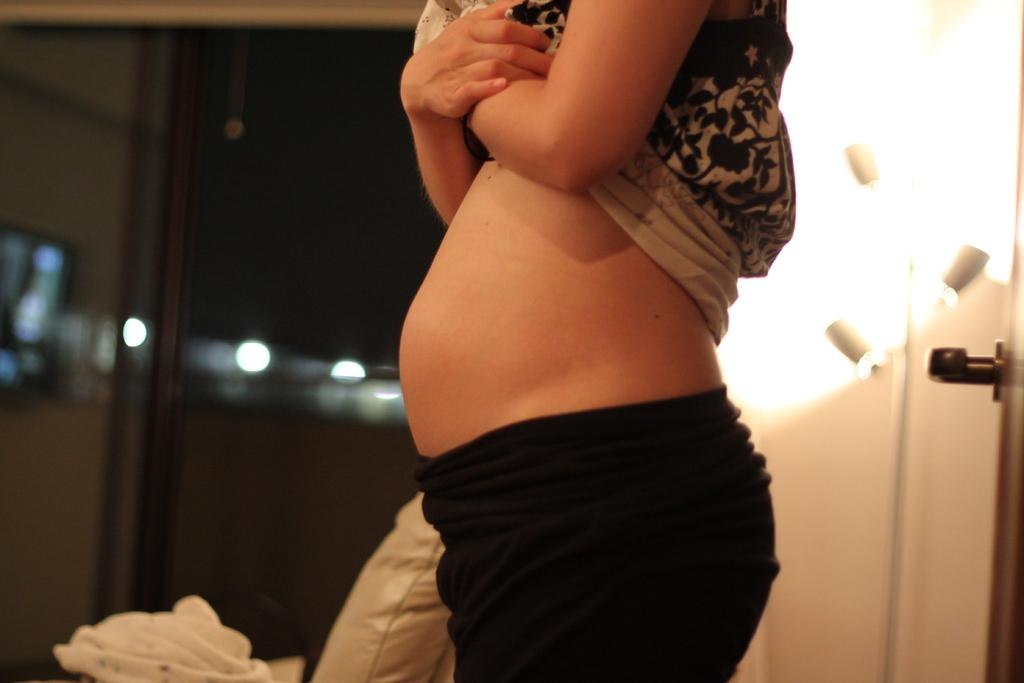Who is present in the image? There is a woman in the image. What is the woman wearing on her lower body? The woman is wearing black pants. What is the woman wearing on her upper body? The woman is wearing a white top. What can be seen in the background of the image? There is a white door and a pillow in the background of the image. What type of rod is the woman using to hang her apparel in the image? There is no rod or apparel visible in the image; the woman is wearing black pants and a white top. 